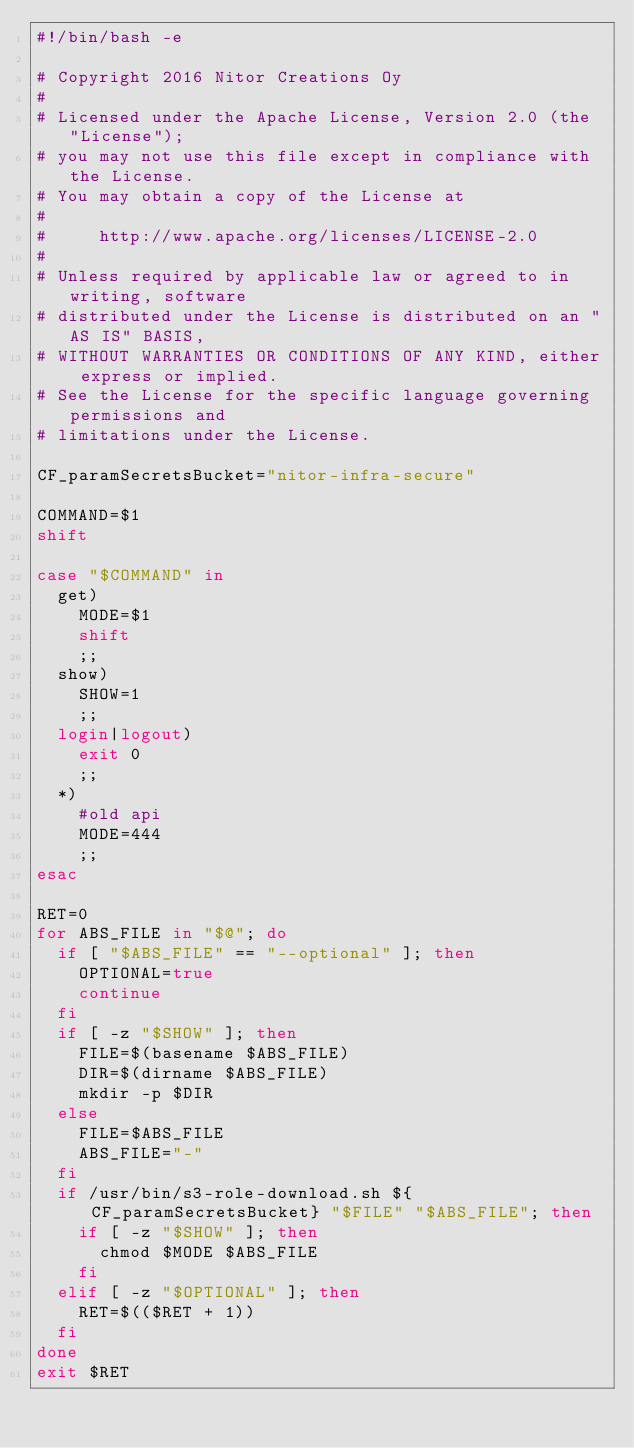<code> <loc_0><loc_0><loc_500><loc_500><_Bash_>#!/bin/bash -e

# Copyright 2016 Nitor Creations Oy
#
# Licensed under the Apache License, Version 2.0 (the "License");
# you may not use this file except in compliance with the License.
# You may obtain a copy of the License at
#
#     http://www.apache.org/licenses/LICENSE-2.0
#
# Unless required by applicable law or agreed to in writing, software
# distributed under the License is distributed on an "AS IS" BASIS,
# WITHOUT WARRANTIES OR CONDITIONS OF ANY KIND, either express or implied.
# See the License for the specific language governing permissions and
# limitations under the License.

CF_paramSecretsBucket="nitor-infra-secure"

COMMAND=$1
shift

case "$COMMAND" in
  get)
    MODE=$1
    shift
    ;;
  show)
    SHOW=1
    ;;
  login|logout)
    exit 0
    ;;
  *)
    #old api
    MODE=444
    ;;
esac

RET=0
for ABS_FILE in "$@"; do
  if [ "$ABS_FILE" == "--optional" ]; then
    OPTIONAL=true
    continue
  fi
  if [ -z "$SHOW" ]; then
    FILE=$(basename $ABS_FILE)
    DIR=$(dirname $ABS_FILE)
    mkdir -p $DIR
  else
    FILE=$ABS_FILE
    ABS_FILE="-"
  fi
  if /usr/bin/s3-role-download.sh ${CF_paramSecretsBucket} "$FILE" "$ABS_FILE"; then
    if [ -z "$SHOW" ]; then
      chmod $MODE $ABS_FILE
    fi
  elif [ -z "$OPTIONAL" ]; then
    RET=$(($RET + 1))
  fi
done
exit $RET
</code> 